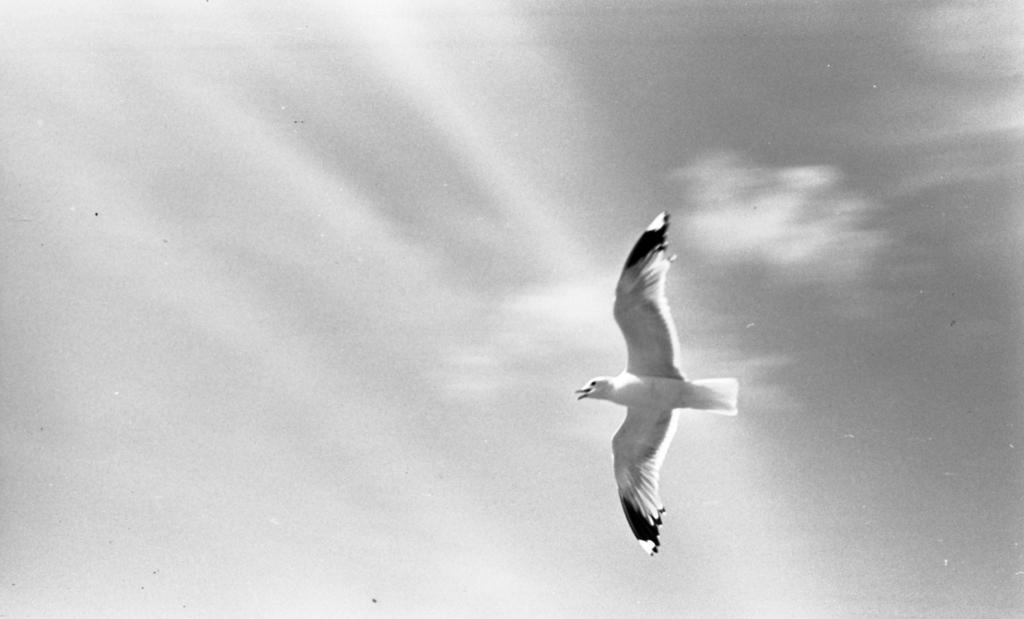What type of animal can be seen in the image? There is a bird in the image. What is the bird doing in the image? The bird is flying in the sky. Where are the chickens located in the image? There are no chickens present in the image; it features a bird flying in the sky. What type of fuel is being used by the bird to fly in the image? Birds do not use fuel to fly; they have wings that allow them to fly using their own energy. 